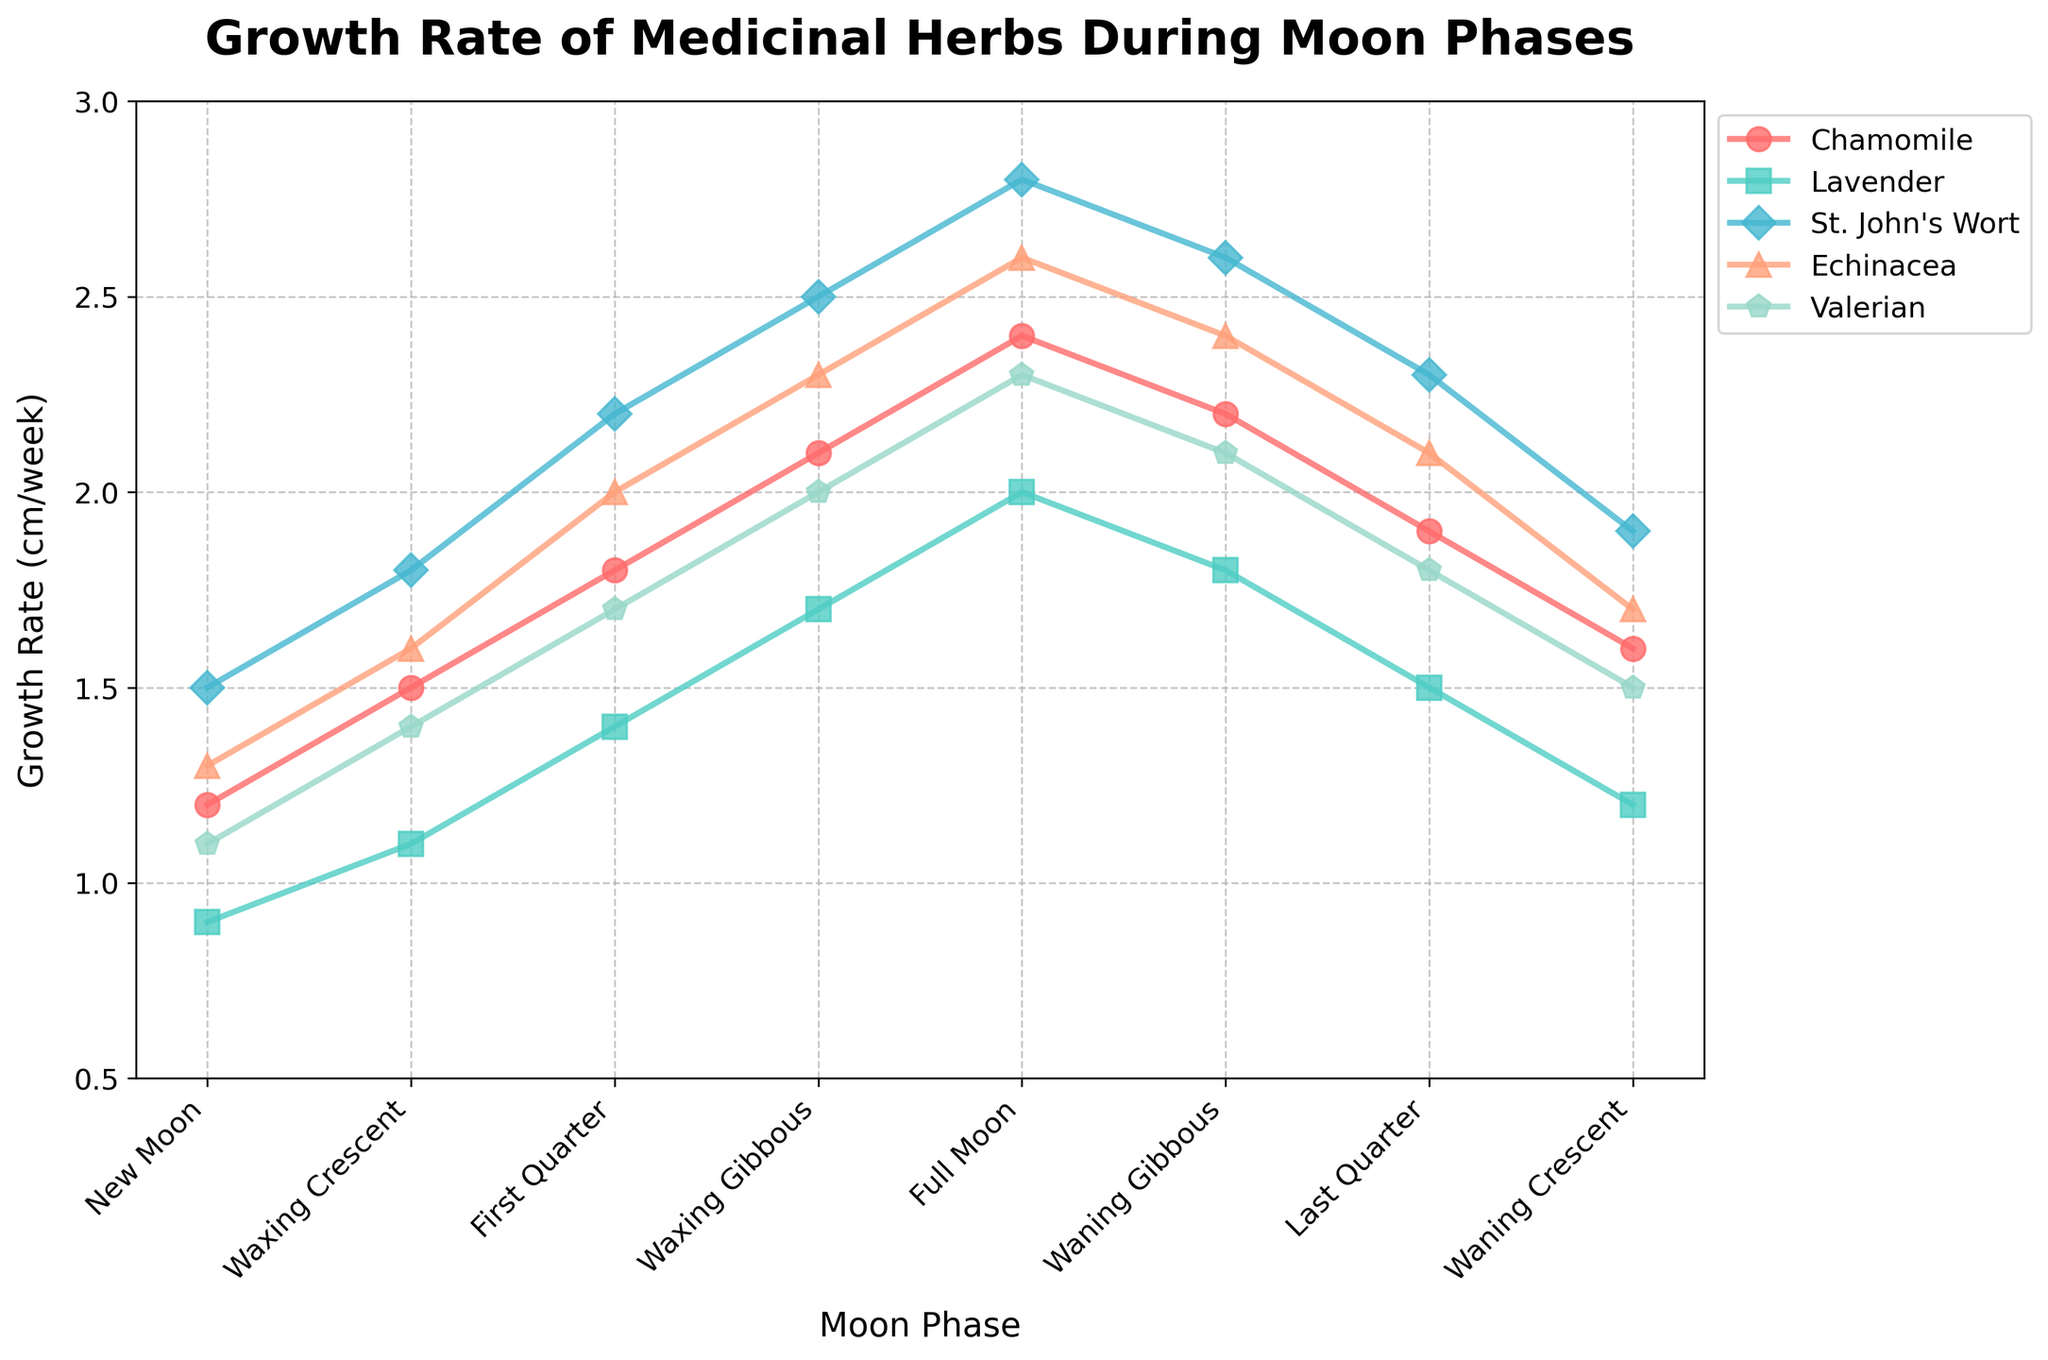Which moon phase shows the highest growth rate for Chamomile? Identify the peak value of Chamomile across all moon phases and find the corresponding moon phase. The highest growth rate for Chamomile is 2.4 cm/week during the Full Moon phase.
Answer: Full Moon How does the growth rate of Lavender during the Full Moon compare to its growth rate during the New Moon? Compare the two values for Lavender during the Full Moon and the New Moon. Lavender grows at 2.0 cm/week during the Full Moon and 0.9 cm/week during the New Moon, meaning it grows more during the Full Moon.
Answer: Full Moon is greater What is the average growth rate of Echinacea across all moon phases? Sum the growth rates of Echinacea across all moon phases and divide by the number of phases (8). The sum is 1.3 + 1.6 + 2.0 + 2.3 + 2.6 + 2.4 + 2.1 + 1.7 = 16.0, so the average growth rate is 16.0/8 = 2.0 cm/week.
Answer: 2.0 cm/week Which herb shows the most significant variation in growth rate across different moon phases? Calculate the range (difference between maximum and minimum values) for each herb's growth rate across moon phases. The ranges are Chamomile (2.4 - 1.2 = 1.2), Lavender (2.0 - 0.9 = 1.1), St. John's Wort (2.8 - 1.5 = 1.3), Echinacea (2.6 - 1.3 = 1.3), and Valerian (2.3 - 1.1 = 1.2). St. John's Wort and Echinacea show the most significant variation.
Answer: St. John's Wort and Echinacea During which moon phase is the growth rate of herbs closest to the average growth rate of Lavender throughout all moon phases? First, calculate the average growth rate of Lavender: (0.9 + 1.1 + 1.4 + 1.7 + 2.0 + 1.8 + 1.5 + 1.2) / 8 = 1.45 cm/week. Identify which moon phase's growth rate is closest to 1.45 cm/week. Waxing Crescent has the closest growth rate for Lavender (1.1 cm/week).
Answer: Waxing Crescent Compare the growth rate of Valerian during the First Quarter and Last Quarter phases. Identify the growth rates of Valerian during the First Quarter (1.7 cm/week) and Last Quarter (1.8 cm/week) and calculate the difference. Valerian grows slightly more during the Last Quarter.
Answer: Last Quarter is greater What's the total growth rate contribution of Chamomile and Echinacea during the Waxing Gibbous phase? Sum the growth rates of Chamomile and Echinacea during the Waxing Gibbous phase. Chamomile grows at 2.1 cm/week and Echinacea at 2.3 cm/week, so the total is 2.1 + 2.3 = 4.4 cm/week.
Answer: 4.4 cm/week Which moon phase exhibits the least growth rate consistently across all herbs? Identify the moon phase with the lowest growth rate values when comparing all herbs. The New Moon phase consistently has the least growth rates when compared to values from other phases.
Answer: New Moon 